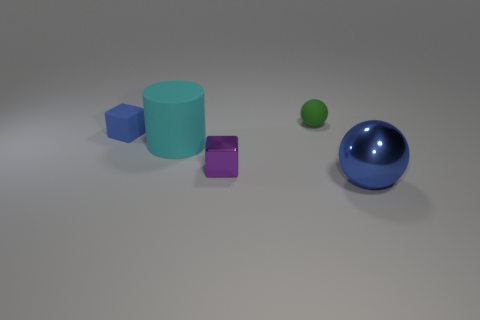Add 5 big blue balls. How many objects exist? 10 Subtract all cylinders. How many objects are left? 4 Add 2 small matte blocks. How many small matte blocks are left? 3 Add 5 tiny yellow blocks. How many tiny yellow blocks exist? 5 Subtract 0 green cylinders. How many objects are left? 5 Subtract all tiny matte balls. Subtract all large cyan things. How many objects are left? 3 